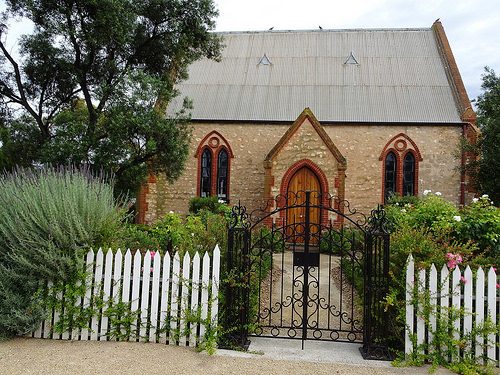<image>
Is there a gate in front of the home? Yes. The gate is positioned in front of the home, appearing closer to the camera viewpoint. 